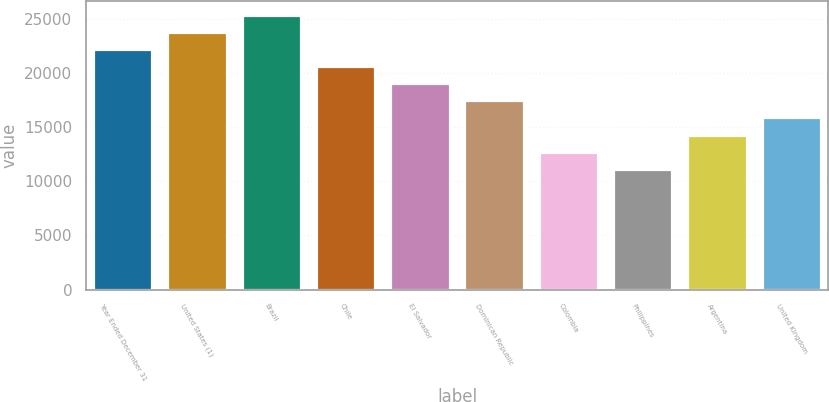<chart> <loc_0><loc_0><loc_500><loc_500><bar_chart><fcel>Year Ended December 31<fcel>United States (1)<fcel>Brazil<fcel>Chile<fcel>El Salvador<fcel>Dominican Republic<fcel>Colombia<fcel>Philippines<fcel>Argentina<fcel>United Kingdom<nl><fcel>22219<fcel>23801<fcel>25383<fcel>20637<fcel>19055<fcel>17473<fcel>12727<fcel>11145<fcel>14309<fcel>15891<nl></chart> 